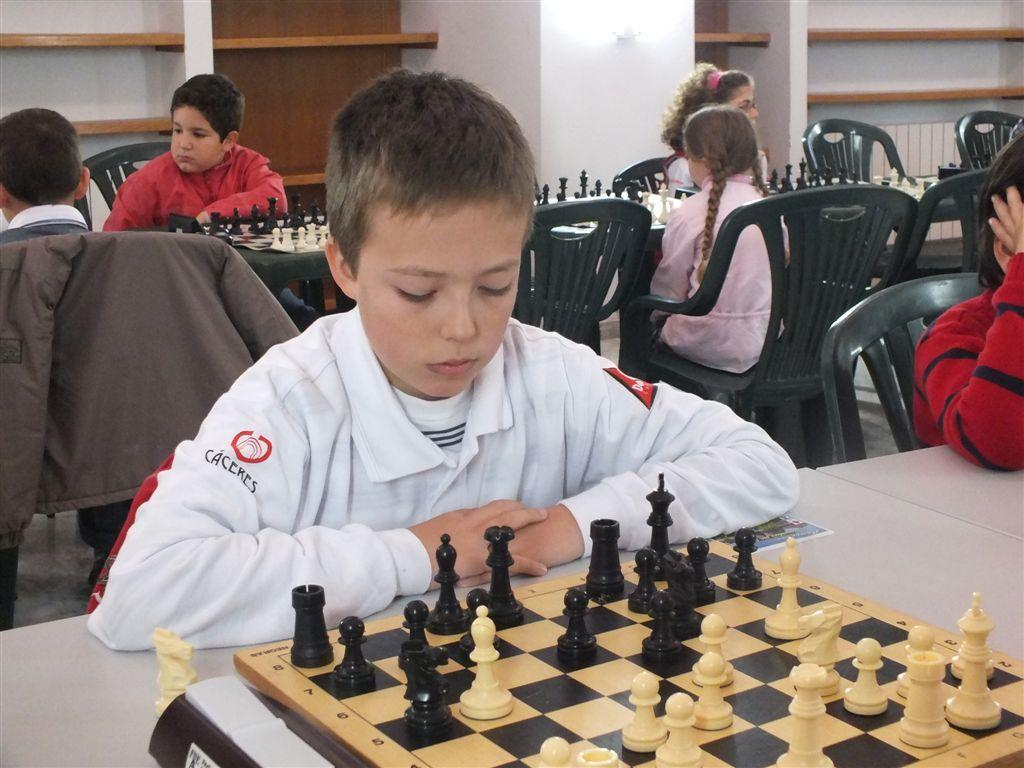What are the people in the image doing? The people in the image are playing chess. What objects are the people using to play the game? The people are using a chessboard, which is placed on a table. What positions are the people in while playing the game? The people are sitting on chairs in the image. What type of beef is being served on the table in the image? There is no beef present in the image; the people are playing chess on a chessboard placed on a table. Can you describe the garden visible through the window in the image? There is no window or garden visible in the image; it only shows people playing chess on chairs. 